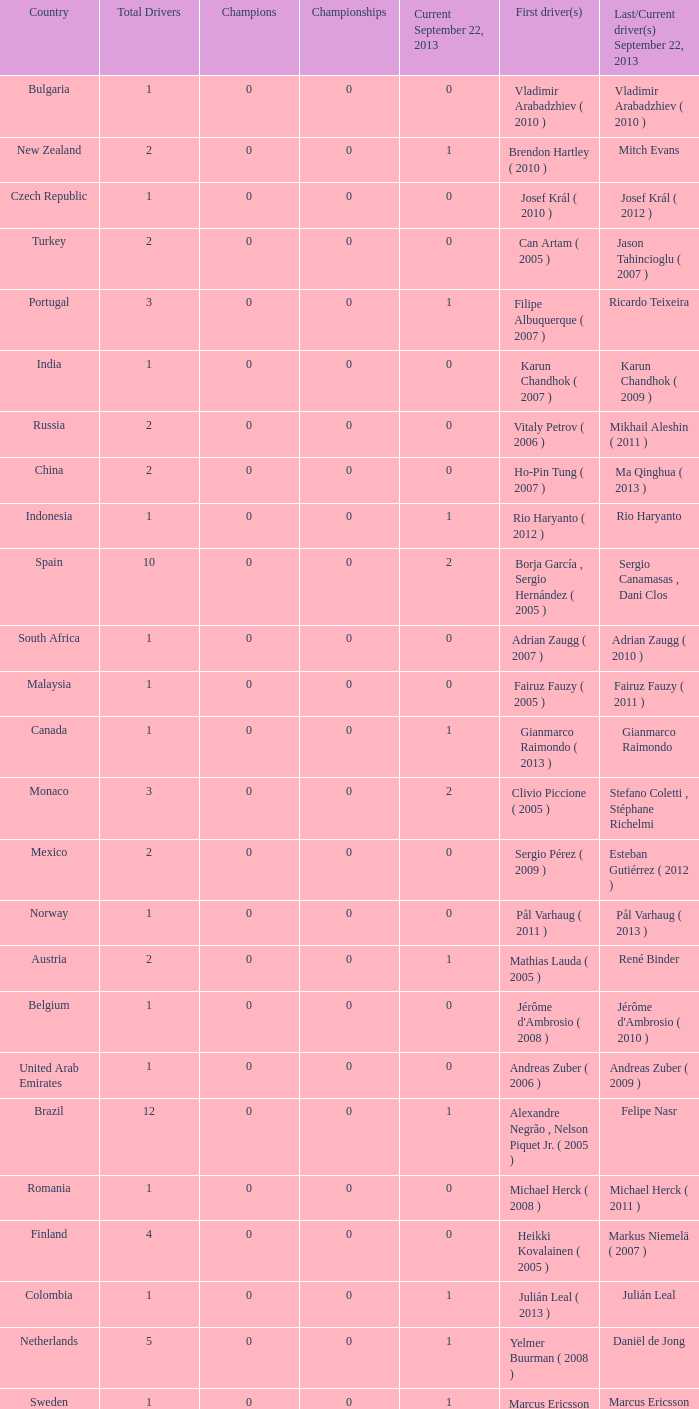How many champions were there when the first driver was hiroki yoshimoto ( 2005 )? 0.0. 